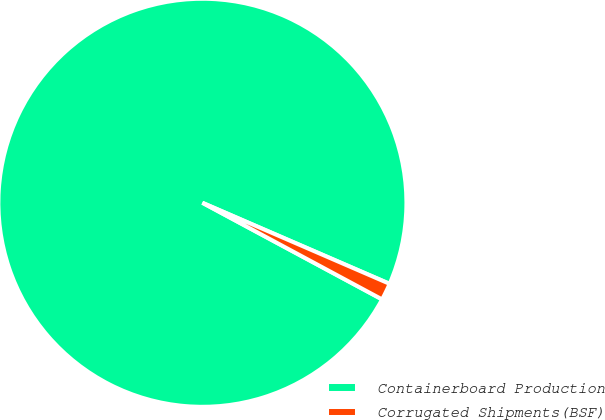Convert chart. <chart><loc_0><loc_0><loc_500><loc_500><pie_chart><fcel>Containerboard Production<fcel>Corrugated Shipments(BSF)<nl><fcel>98.65%<fcel>1.35%<nl></chart> 